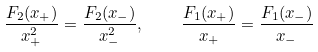<formula> <loc_0><loc_0><loc_500><loc_500>\frac { F _ { 2 } ( x _ { + } ) } { x _ { + } ^ { 2 } } = \frac { F _ { 2 } ( x _ { - } ) } { x _ { - } ^ { 2 } } , \quad \frac { F _ { 1 } ( x _ { + } ) } { x _ { + } } = \frac { F _ { 1 } ( x _ { - } ) } { x _ { - } }</formula> 